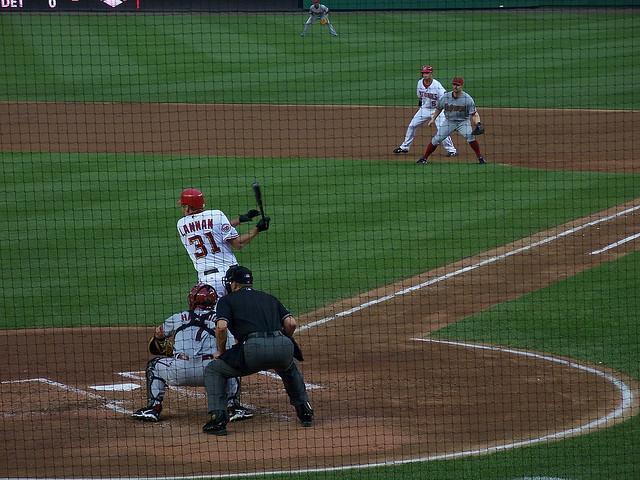What base is the player in white behind the grey suited player supposed to be on?
Choose the correct response, then elucidate: 'Answer: answer
Rationale: rationale.'
Options: First base, second base, home base, third base. Answer: first base.
Rationale: The batter would run from where he is which is home base to the very first white plate on our right before the ball is caught and he would be out. 